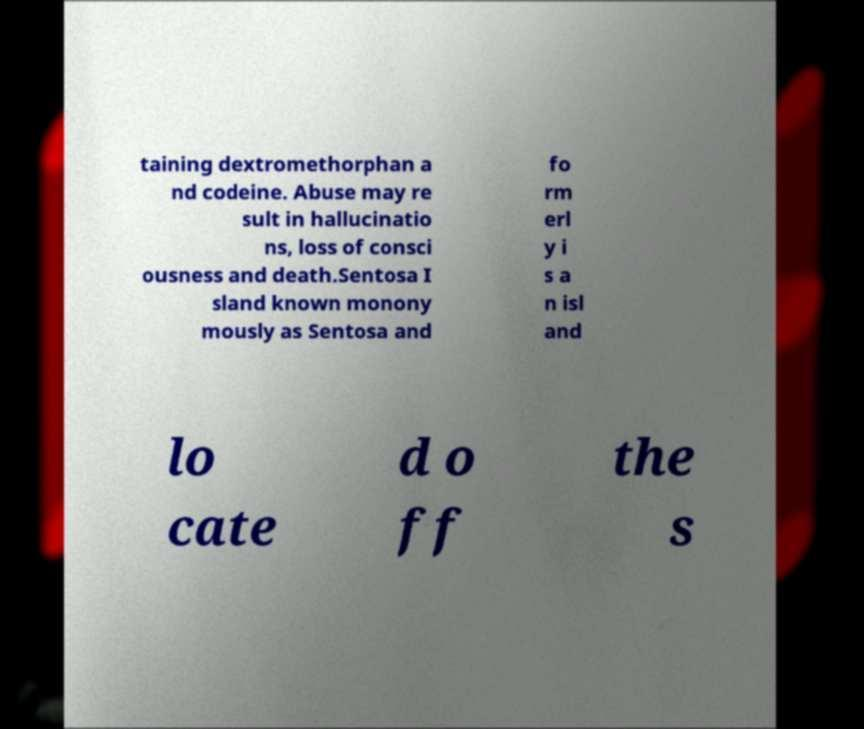Can you read and provide the text displayed in the image?This photo seems to have some interesting text. Can you extract and type it out for me? taining dextromethorphan a nd codeine. Abuse may re sult in hallucinatio ns, loss of consci ousness and death.Sentosa I sland known monony mously as Sentosa and fo rm erl y i s a n isl and lo cate d o ff the s 